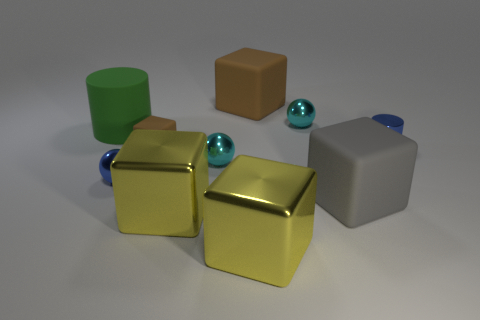Subtract all gray cubes. How many cubes are left? 4 Subtract all big brown rubber cubes. How many cubes are left? 4 Subtract all blue blocks. Subtract all purple balls. How many blocks are left? 5 Subtract all balls. How many objects are left? 7 Add 2 large cyan matte objects. How many large cyan matte objects exist? 2 Subtract 1 blue balls. How many objects are left? 9 Subtract all tiny cyan metallic cubes. Subtract all small cylinders. How many objects are left? 9 Add 6 tiny shiny spheres. How many tiny shiny spheres are left? 9 